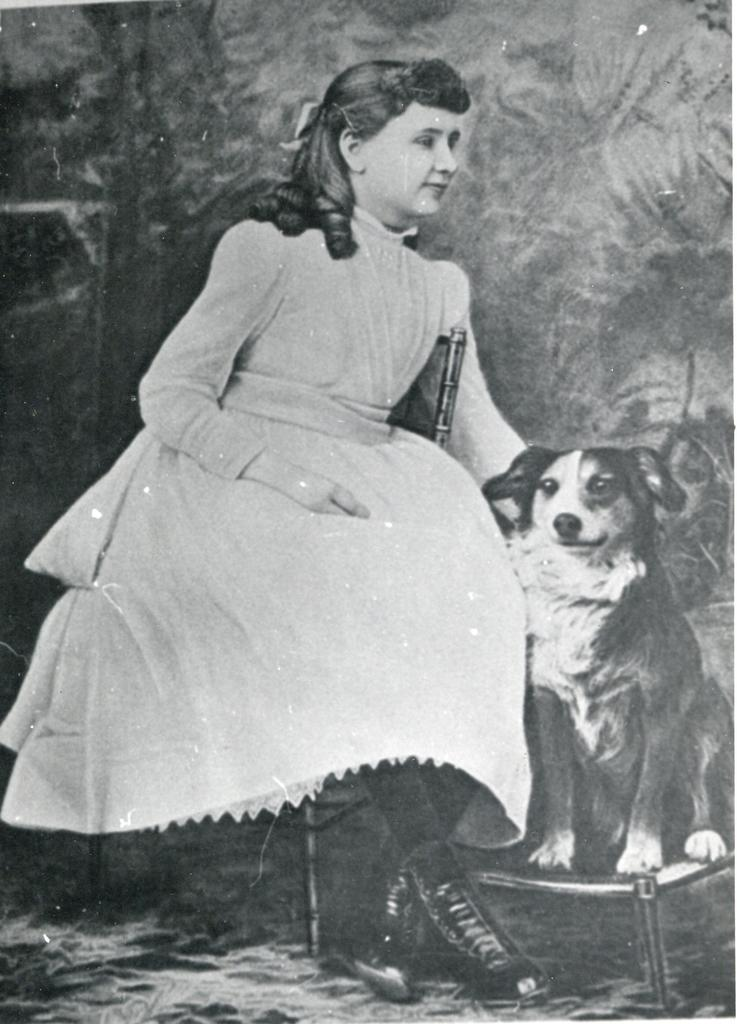What is the lady in the image doing? The lady is sitting on a chair in the image. Is there any other living creature in the image besides the lady? Yes, there is a dog on a stand near the lady. What is the color scheme of the image? The image is black and white. How many ants can be seen crawling on the chair in the image? There are no ants visible in the image; it only features a lady sitting on a chair and a dog on a stand. 